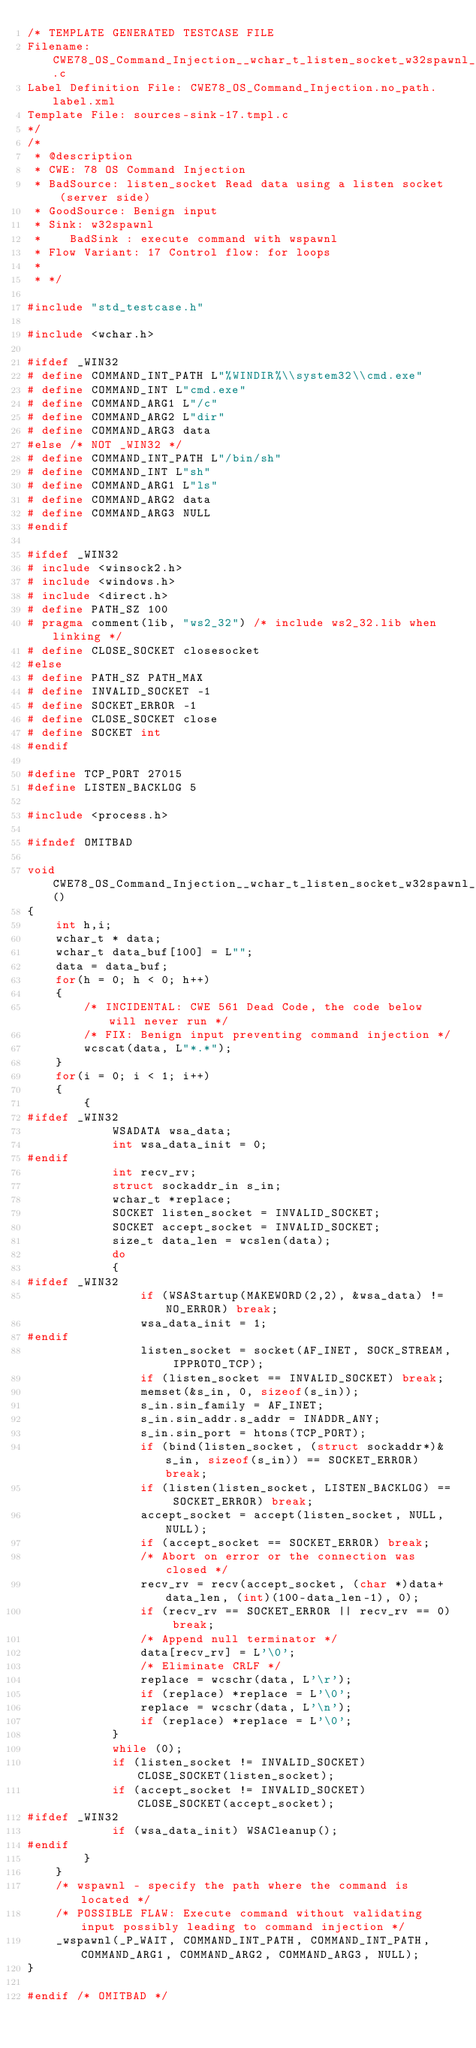Convert code to text. <code><loc_0><loc_0><loc_500><loc_500><_C_>/* TEMPLATE GENERATED TESTCASE FILE
Filename: CWE78_OS_Command_Injection__wchar_t_listen_socket_w32spawnl_17.c
Label Definition File: CWE78_OS_Command_Injection.no_path.label.xml
Template File: sources-sink-17.tmpl.c
*/
/*
 * @description
 * CWE: 78 OS Command Injection
 * BadSource: listen_socket Read data using a listen socket (server side)
 * GoodSource: Benign input
 * Sink: w32spawnl
 *    BadSink : execute command with wspawnl
 * Flow Variant: 17 Control flow: for loops
 *
 * */

#include "std_testcase.h"

#include <wchar.h>

#ifdef _WIN32
# define COMMAND_INT_PATH L"%WINDIR%\\system32\\cmd.exe"
# define COMMAND_INT L"cmd.exe"
# define COMMAND_ARG1 L"/c"
# define COMMAND_ARG2 L"dir"
# define COMMAND_ARG3 data
#else /* NOT _WIN32 */
# define COMMAND_INT_PATH L"/bin/sh"
# define COMMAND_INT L"sh"
# define COMMAND_ARG1 L"ls"
# define COMMAND_ARG2 data
# define COMMAND_ARG3 NULL
#endif

#ifdef _WIN32
# include <winsock2.h>
# include <windows.h>
# include <direct.h>
# define PATH_SZ 100
# pragma comment(lib, "ws2_32") /* include ws2_32.lib when linking */
# define CLOSE_SOCKET closesocket
#else
# define PATH_SZ PATH_MAX
# define INVALID_SOCKET -1
# define SOCKET_ERROR -1
# define CLOSE_SOCKET close
# define SOCKET int
#endif

#define TCP_PORT 27015
#define LISTEN_BACKLOG 5

#include <process.h>

#ifndef OMITBAD

void CWE78_OS_Command_Injection__wchar_t_listen_socket_w32spawnl_17_bad()
{
    int h,i;
    wchar_t * data;
    wchar_t data_buf[100] = L"";
    data = data_buf;
    for(h = 0; h < 0; h++)
    {
        /* INCIDENTAL: CWE 561 Dead Code, the code below will never run */
        /* FIX: Benign input preventing command injection */
        wcscat(data, L"*.*");
    }
    for(i = 0; i < 1; i++)
    {
        {
#ifdef _WIN32
            WSADATA wsa_data;
            int wsa_data_init = 0;
#endif
            int recv_rv;
            struct sockaddr_in s_in;
            wchar_t *replace;
            SOCKET listen_socket = INVALID_SOCKET;
            SOCKET accept_socket = INVALID_SOCKET;
            size_t data_len = wcslen(data);
            do
            {
#ifdef _WIN32
                if (WSAStartup(MAKEWORD(2,2), &wsa_data) != NO_ERROR) break;
                wsa_data_init = 1;
#endif
                listen_socket = socket(AF_INET, SOCK_STREAM, IPPROTO_TCP);
                if (listen_socket == INVALID_SOCKET) break;
                memset(&s_in, 0, sizeof(s_in));
                s_in.sin_family = AF_INET;
                s_in.sin_addr.s_addr = INADDR_ANY;
                s_in.sin_port = htons(TCP_PORT);
                if (bind(listen_socket, (struct sockaddr*)&s_in, sizeof(s_in)) == SOCKET_ERROR) break;
                if (listen(listen_socket, LISTEN_BACKLOG) == SOCKET_ERROR) break;
                accept_socket = accept(listen_socket, NULL, NULL);
                if (accept_socket == SOCKET_ERROR) break;
                /* Abort on error or the connection was closed */
                recv_rv = recv(accept_socket, (char *)data+data_len, (int)(100-data_len-1), 0);
                if (recv_rv == SOCKET_ERROR || recv_rv == 0) break;
                /* Append null terminator */
                data[recv_rv] = L'\0';
                /* Eliminate CRLF */
                replace = wcschr(data, L'\r');
                if (replace) *replace = L'\0';
                replace = wcschr(data, L'\n');
                if (replace) *replace = L'\0';
            }
            while (0);
            if (listen_socket != INVALID_SOCKET) CLOSE_SOCKET(listen_socket);
            if (accept_socket != INVALID_SOCKET) CLOSE_SOCKET(accept_socket);
#ifdef _WIN32
            if (wsa_data_init) WSACleanup();
#endif
        }
    }
    /* wspawnl - specify the path where the command is located */
    /* POSSIBLE FLAW: Execute command without validating input possibly leading to command injection */
    _wspawnl(_P_WAIT, COMMAND_INT_PATH, COMMAND_INT_PATH, COMMAND_ARG1, COMMAND_ARG2, COMMAND_ARG3, NULL);
}

#endif /* OMITBAD */
</code> 